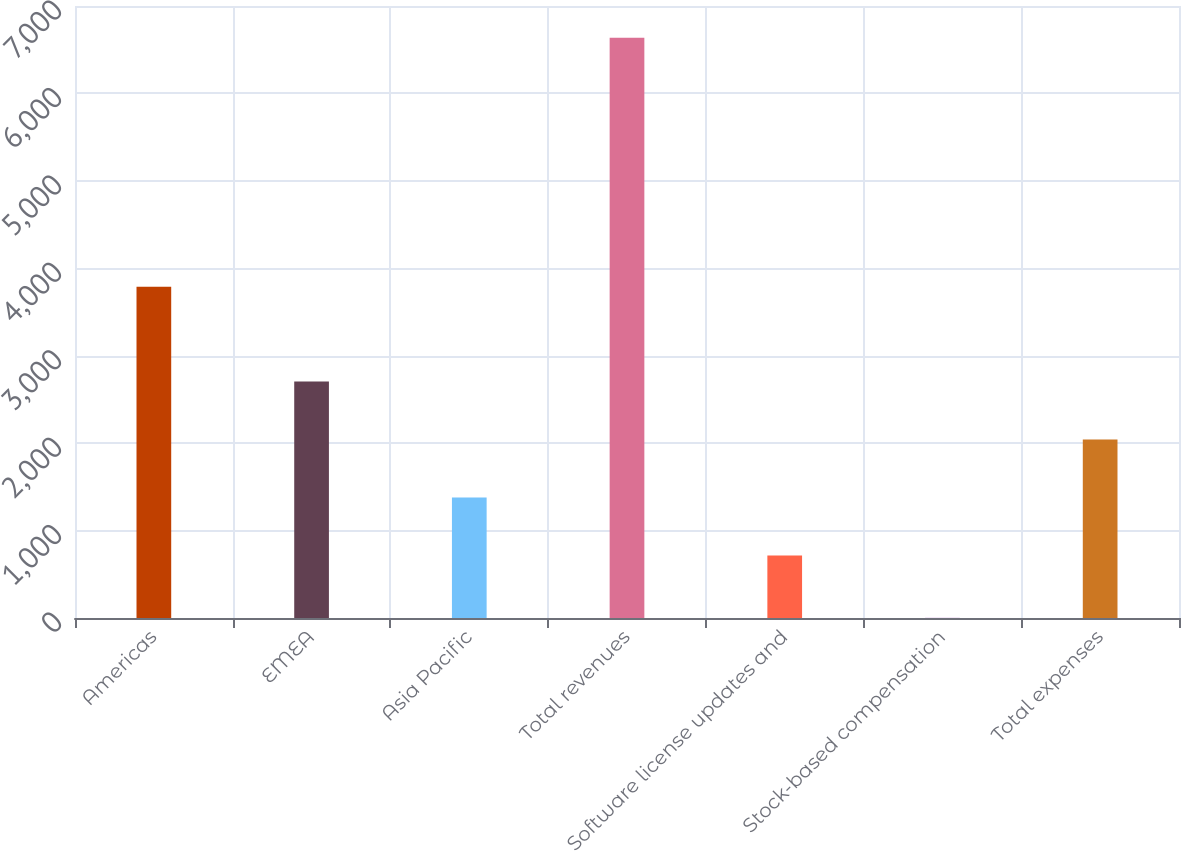Convert chart. <chart><loc_0><loc_0><loc_500><loc_500><bar_chart><fcel>Americas<fcel>EMEA<fcel>Asia Pacific<fcel>Total revenues<fcel>Software license updates and<fcel>Stock-based compensation<fcel>Total expenses<nl><fcel>3790<fcel>2705.9<fcel>1379.3<fcel>6636<fcel>716<fcel>3<fcel>2042.6<nl></chart> 